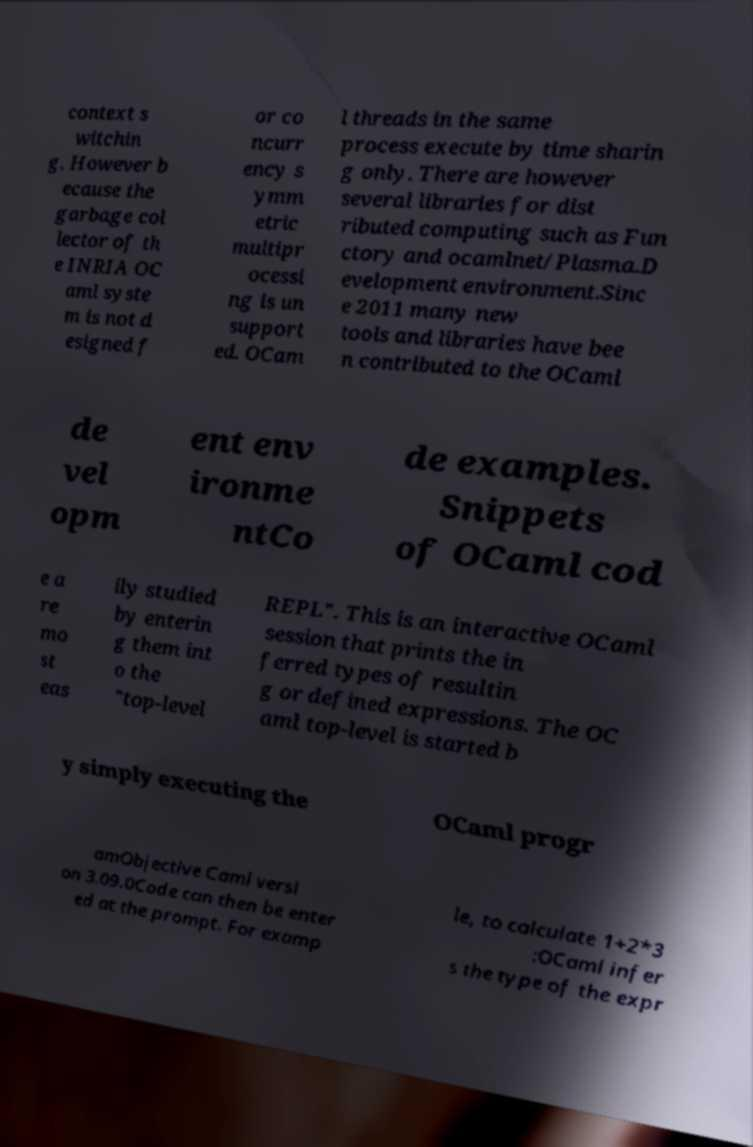For documentation purposes, I need the text within this image transcribed. Could you provide that? context s witchin g. However b ecause the garbage col lector of th e INRIA OC aml syste m is not d esigned f or co ncurr ency s ymm etric multipr ocessi ng is un support ed. OCam l threads in the same process execute by time sharin g only. There are however several libraries for dist ributed computing such as Fun ctory and ocamlnet/Plasma.D evelopment environment.Sinc e 2011 many new tools and libraries have bee n contributed to the OCaml de vel opm ent env ironme ntCo de examples. Snippets of OCaml cod e a re mo st eas ily studied by enterin g them int o the "top-level REPL". This is an interactive OCaml session that prints the in ferred types of resultin g or defined expressions. The OC aml top-level is started b y simply executing the OCaml progr amObjective Caml versi on 3.09.0Code can then be enter ed at the prompt. For examp le, to calculate 1+2*3 :OCaml infer s the type of the expr 